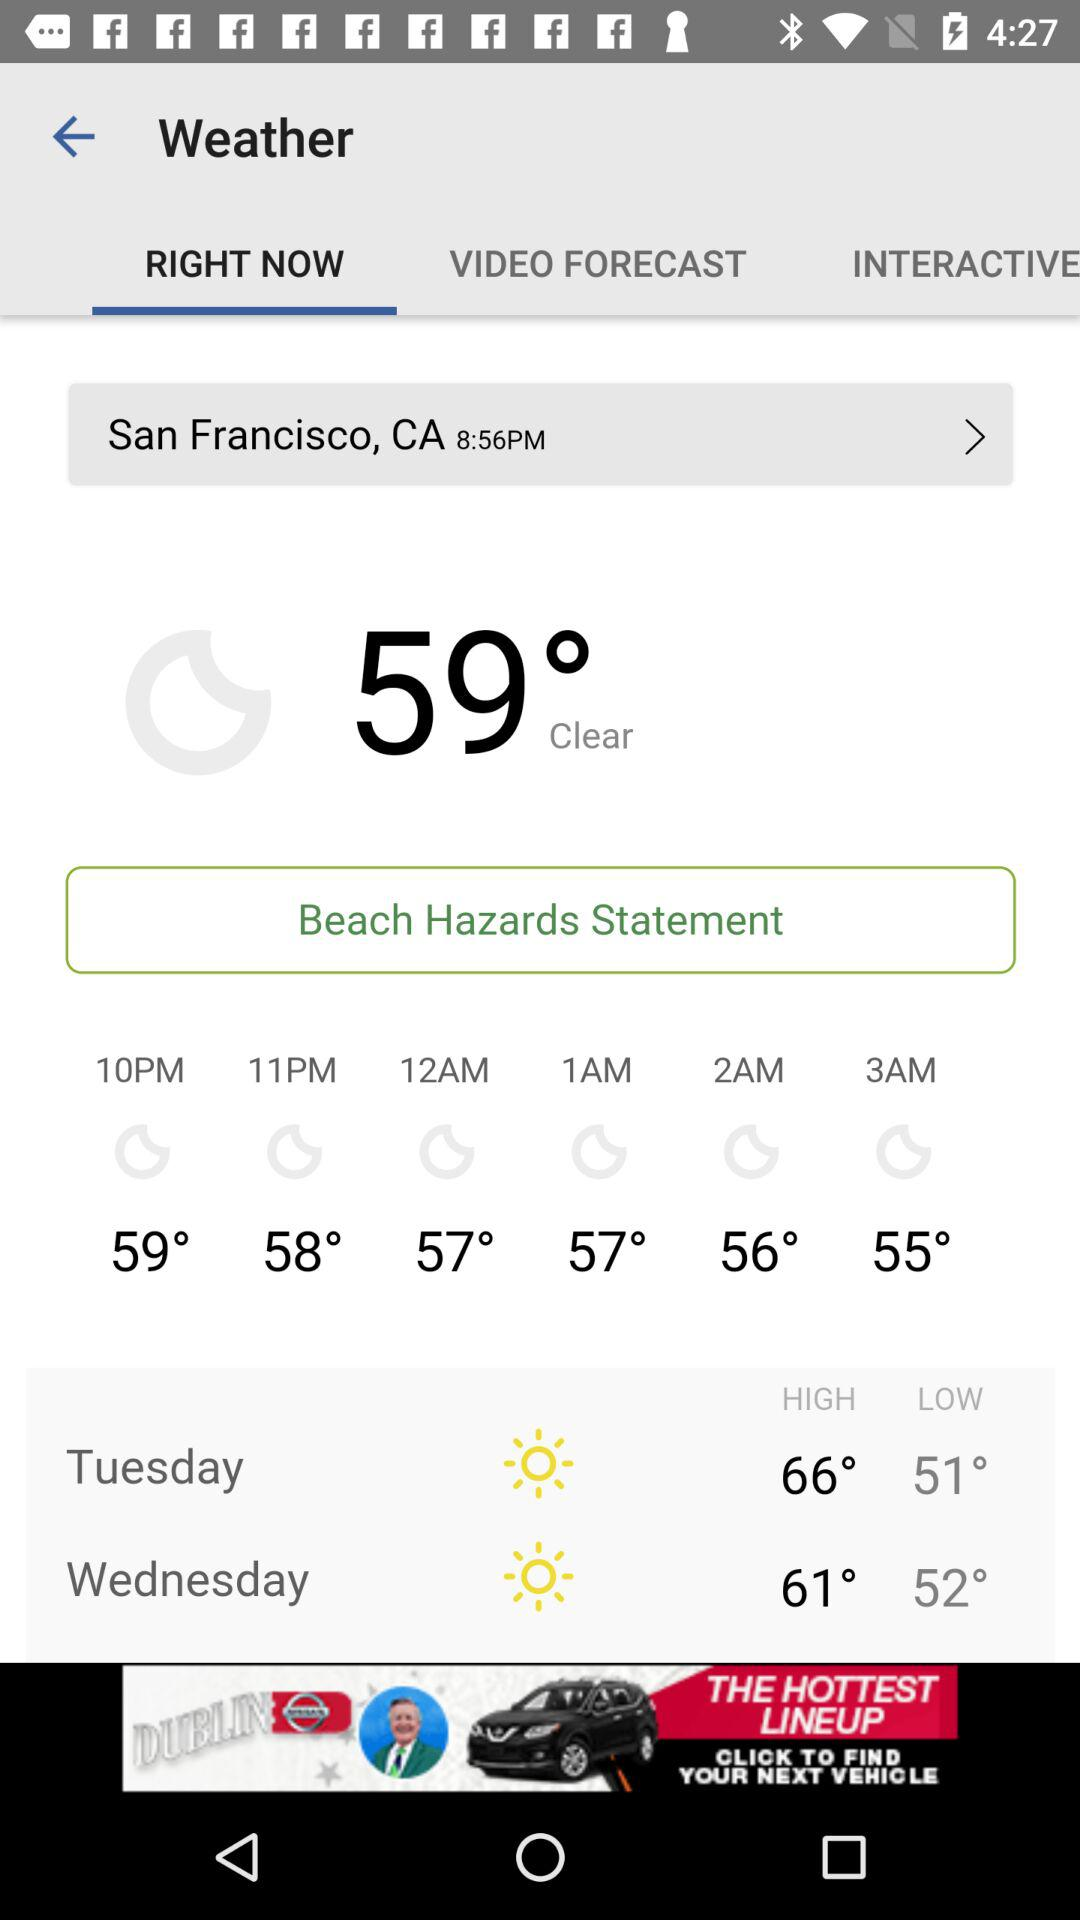At what time is the temperature high?
When the provided information is insufficient, respond with <no answer>. <no answer> 